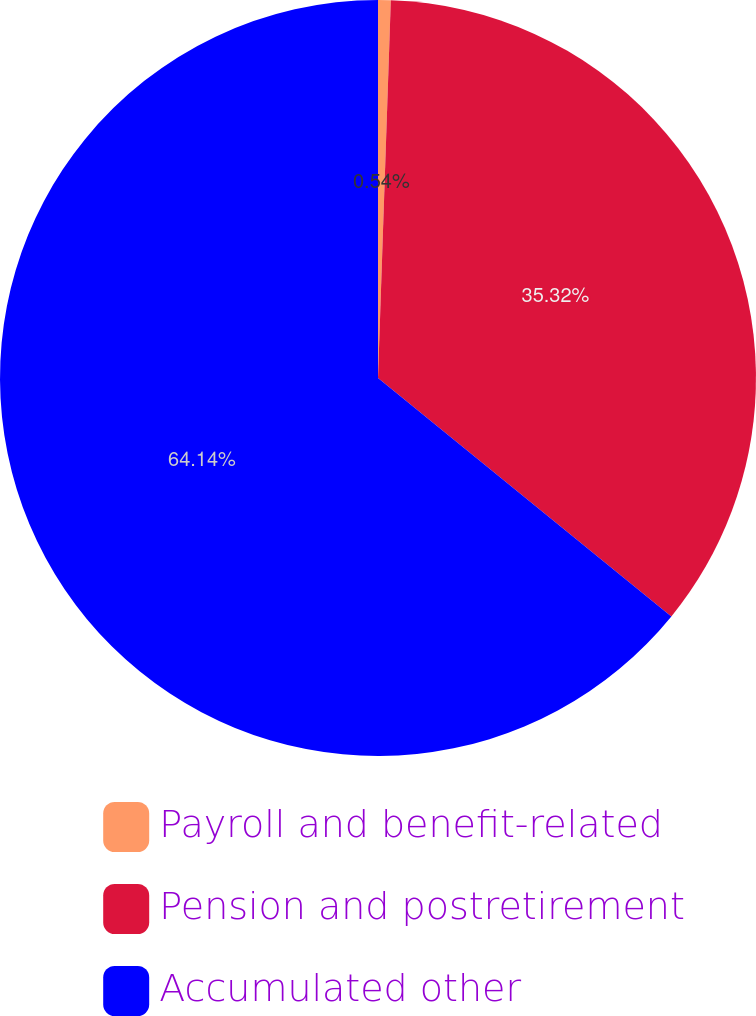<chart> <loc_0><loc_0><loc_500><loc_500><pie_chart><fcel>Payroll and benefit-related<fcel>Pension and postretirement<fcel>Accumulated other<nl><fcel>0.54%<fcel>35.32%<fcel>64.14%<nl></chart> 